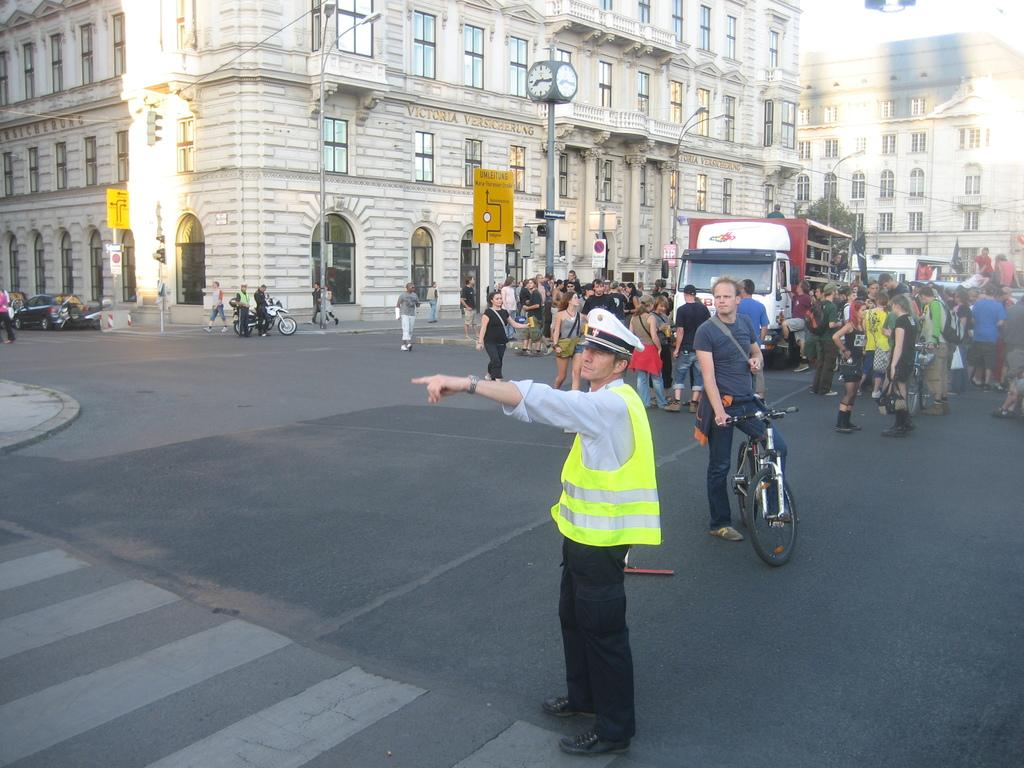What type of structures can be seen in the image? There are buildings in the image. What time-related object is present in the image? There is a clock in the image. What vehicles are visible in the image? There is a truck, a car, a motorcycle, and a bicycle in the image. Are there any people present in the image? Yes, there are people in the image. What type of weather condition is affecting the people in the image? The provided facts do not mention any weather conditions, so it cannot be determined from the image. How does the country influence the design of the buildings in the image? The provided facts do not mention any specific country, so it cannot be determined how the country might influence the design of the buildings. 